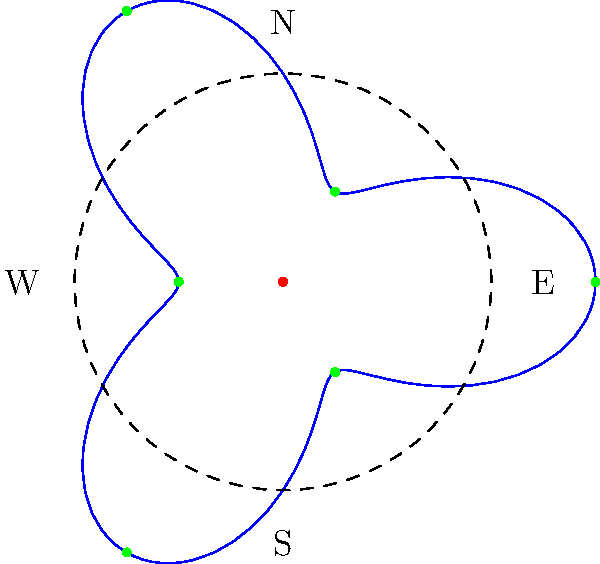As a local business owner supporting school safety, you're helping plan the optimal placement of crossing guards at a complex intersection. The intersection's shape can be modeled using the polar equation $r = 2 + \cos(3\theta)$. If crossing guards need to be placed at the outermost points of this intersection, how many guards are needed, and at what angles (in degrees) should they be positioned? To solve this problem, we need to follow these steps:

1) The equation $r = 2 + \cos(3\theta)$ represents a three-leafed rose curve.

2) To find the outermost points, we need to maximize $r$. This occurs when $\cos(3\theta) = 1$.

3) $\cos(3\theta) = 1$ when $3\theta = 0°, 360°, 720°$, etc.

4) Solving for $\theta$:
   $\theta = 0°, 120°, 240°$

5) These angles repeat every 360°, so these are all the unique maximum points.

6) To convert to the standard coordinate system (where 0° is East and angles increase counterclockwise):
   - 0° remains 0° (East)
   - 120° becomes 360° - 120° = 240° (Southwest)
   - 240° becomes 360° - 240° = 120° (Northwest)

Therefore, three crossing guards are needed, positioned at 0°, 120°, and 240° in the standard coordinate system.
Answer: 3 guards at 0°, 120°, and 240° 